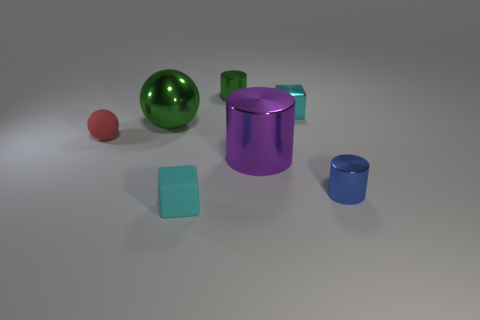There is a red ball; is its size the same as the rubber object to the right of the green metal sphere?
Give a very brief answer. Yes. What number of objects are tiny green metal cylinders or big red cylinders?
Keep it short and to the point. 1. Are there any small brown blocks that have the same material as the blue thing?
Provide a short and direct response. No. The cylinder that is the same color as the big metallic sphere is what size?
Make the answer very short. Small. What is the color of the sphere left of the green shiny object that is in front of the green cylinder?
Your answer should be compact. Red. Does the green ball have the same size as the red thing?
Provide a succinct answer. No. What number of blocks are either purple metallic objects or small cyan metal objects?
Give a very brief answer. 1. There is a small shiny cylinder that is in front of the matte ball; what number of things are in front of it?
Ensure brevity in your answer.  1. Does the big green metallic object have the same shape as the red object?
Offer a very short reply. Yes. There is another thing that is the same shape as the tiny cyan metallic thing; what is its size?
Provide a succinct answer. Small. 